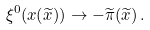Convert formula to latex. <formula><loc_0><loc_0><loc_500><loc_500>\xi ^ { 0 } ( x ( \widetilde { x } ) ) \to - \widetilde { \pi } ( \widetilde { x } ) \, .</formula> 